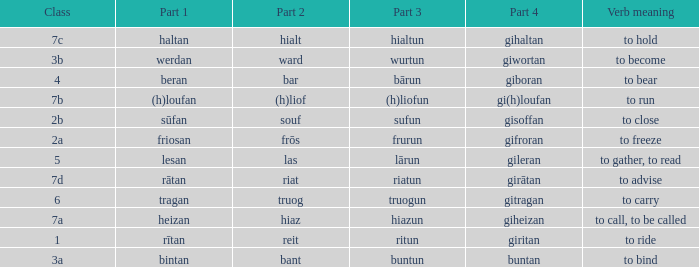What is the verb meaning of the word with part 2 "bant"? To bind. 